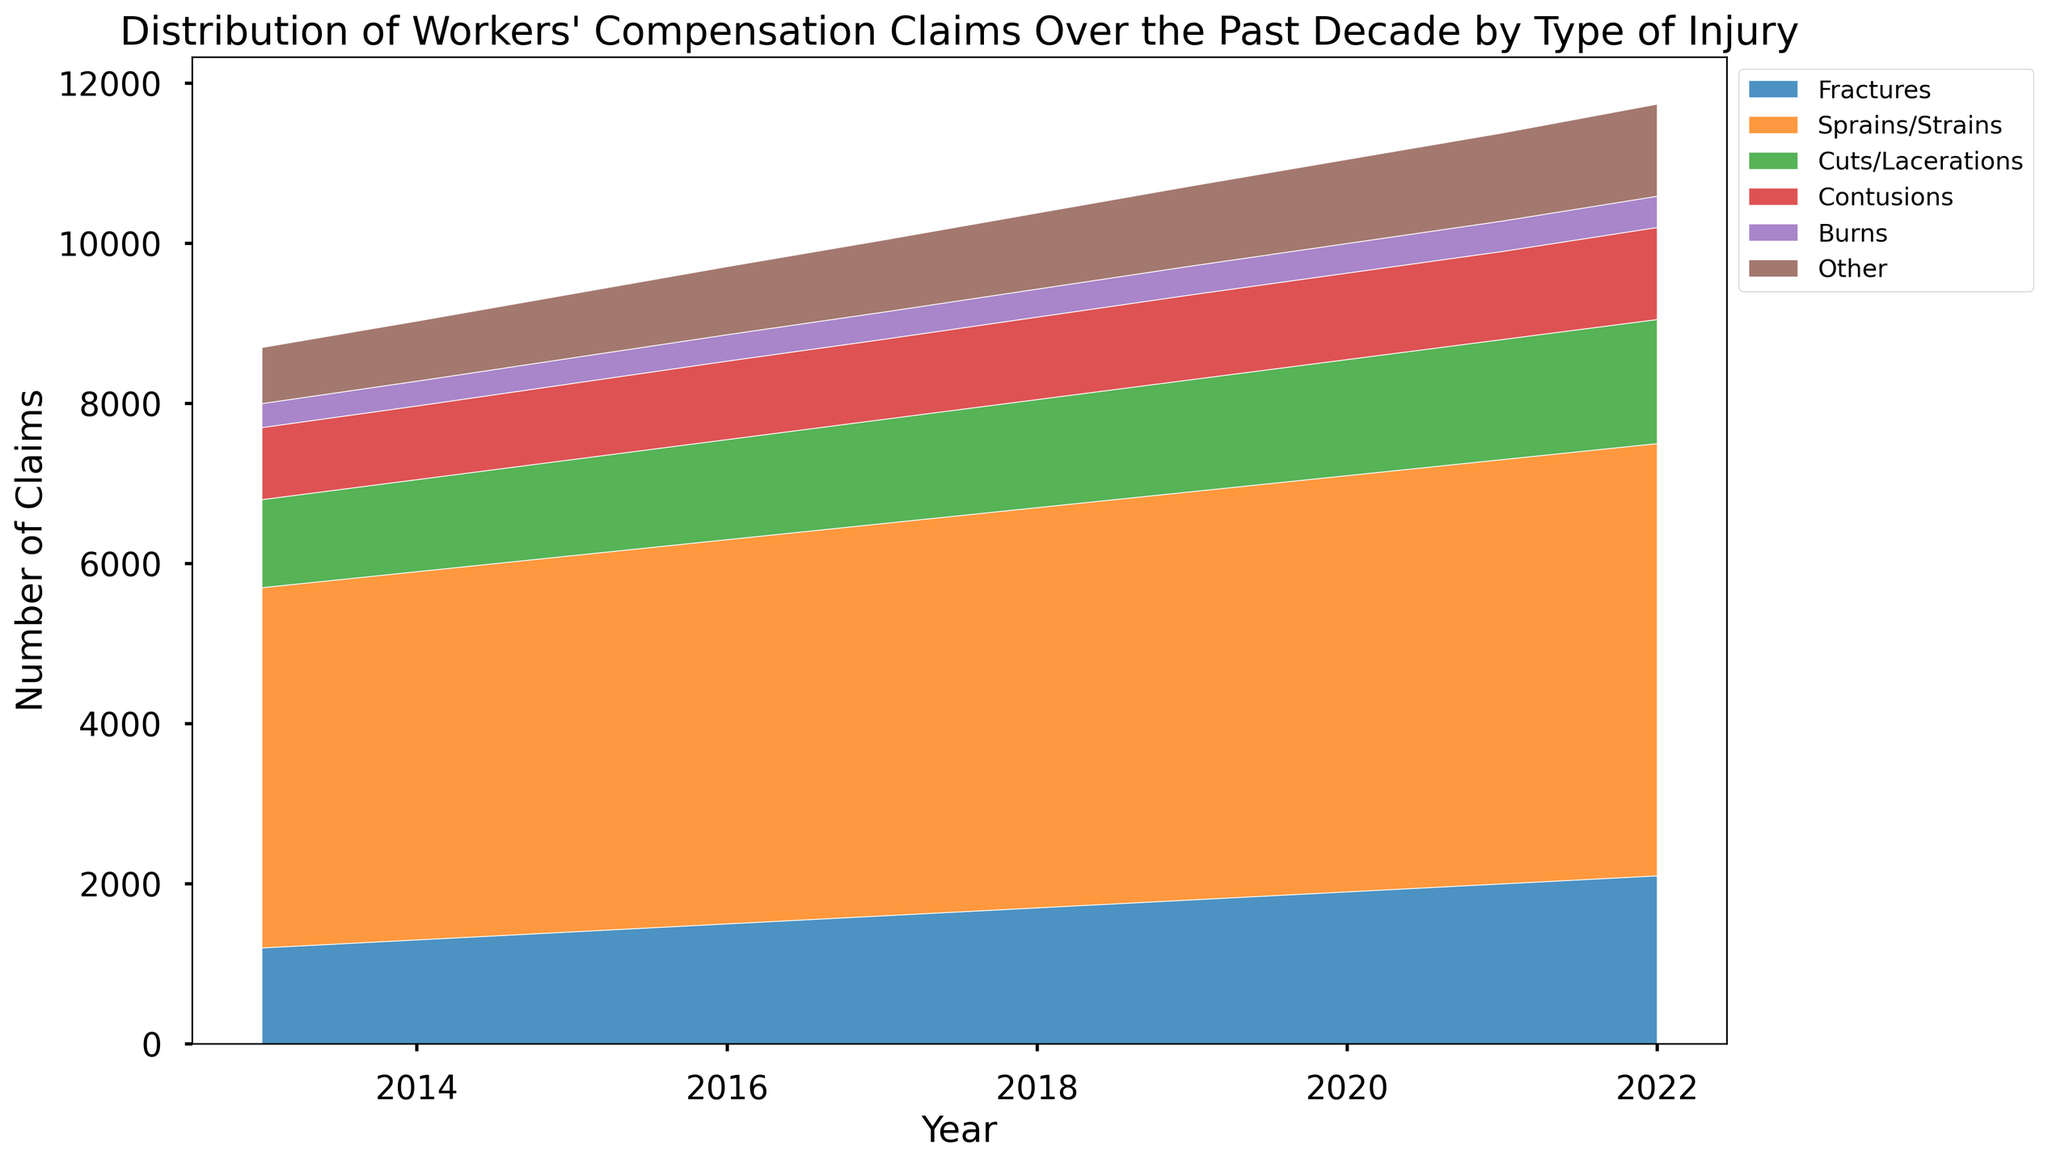What was the total number of Workers' Compensation Claims for the year 2018? Sum the number of claims for each type of injury in 2018: Fractures (1700), Sprains/Strains (5000), Cuts/Lacerations (1350), Contusions (1030), Burns (350), Other (950). Total = 1700 + 5000 + 1350 + 1030 + 350 + 950 = 10380
Answer: 10380 How does the number of Sprains/Strains claims in 2022 compare to that in 2017? In 2017, the claims for Sprains/Strains were 4900. In 2022, they were 5400. To compare, subtract the 2017 value from the 2022 value: 5400 - 4900 = 500
Answer: 500 more in 2022 than 2017 Which injury type had the smallest increase in claims between 2013 and 2022? Calculate the increase for each injury type from 2013 to 2022. Fractures increased by 2100 - 1200 = 900. Sprains/Strains increased by 5400 - 4500 = 900. Cuts/Lacerations increased by 1550 - 1100 = 450. Contusions increased by 1150 - 900 = 250. Burns increased by 390 - 300 = 90. Other increased by 1150 - 700 = 450. The smallest increase was for Burns at 90
Answer: Burns In which year did the total number of claims for Cuts/Lacerations surpass 1300? Track the number of claims for Cuts/Lacerations across the years and note the first instance it exceeds 1300. In 2017, the number is 1300 and in 2018, it's 1350, so it first surpasses 1300 in 2018
Answer: 2018 What is the overall visual trend for the category of Sprains/Strains over the past decade? By observing the height of the Sprains/Strains area on the plot, it is evident that the number of claims increases every year, indicating a consistent upward trend
Answer: Consistent increase Which injury type had the most consistent number of claims per year over the decade? Look for injury types where the heights of the areas are visually consistent each year. The category 'Burns' visually shows little fluctuation compared to others, indicating consistency
Answer: Burns By how much did the total number of claims for Fractures increase between the years 2015 and 2020? Identify the number of claims for Fractures in 2015 (1400) and 2020 (1900), then find the increase by subtracting the 2015 value from the 2020 value: 1900 - 1400 = 500
Answer: 500 What is the overall trend for the total number of claims across all categories from 2013 to 2022? Observing the cumulative height of the areas in the plot, there is a visible upward trend, indicating that the total number of claims for all categories combined has been increasing
Answer: Increasing trend 